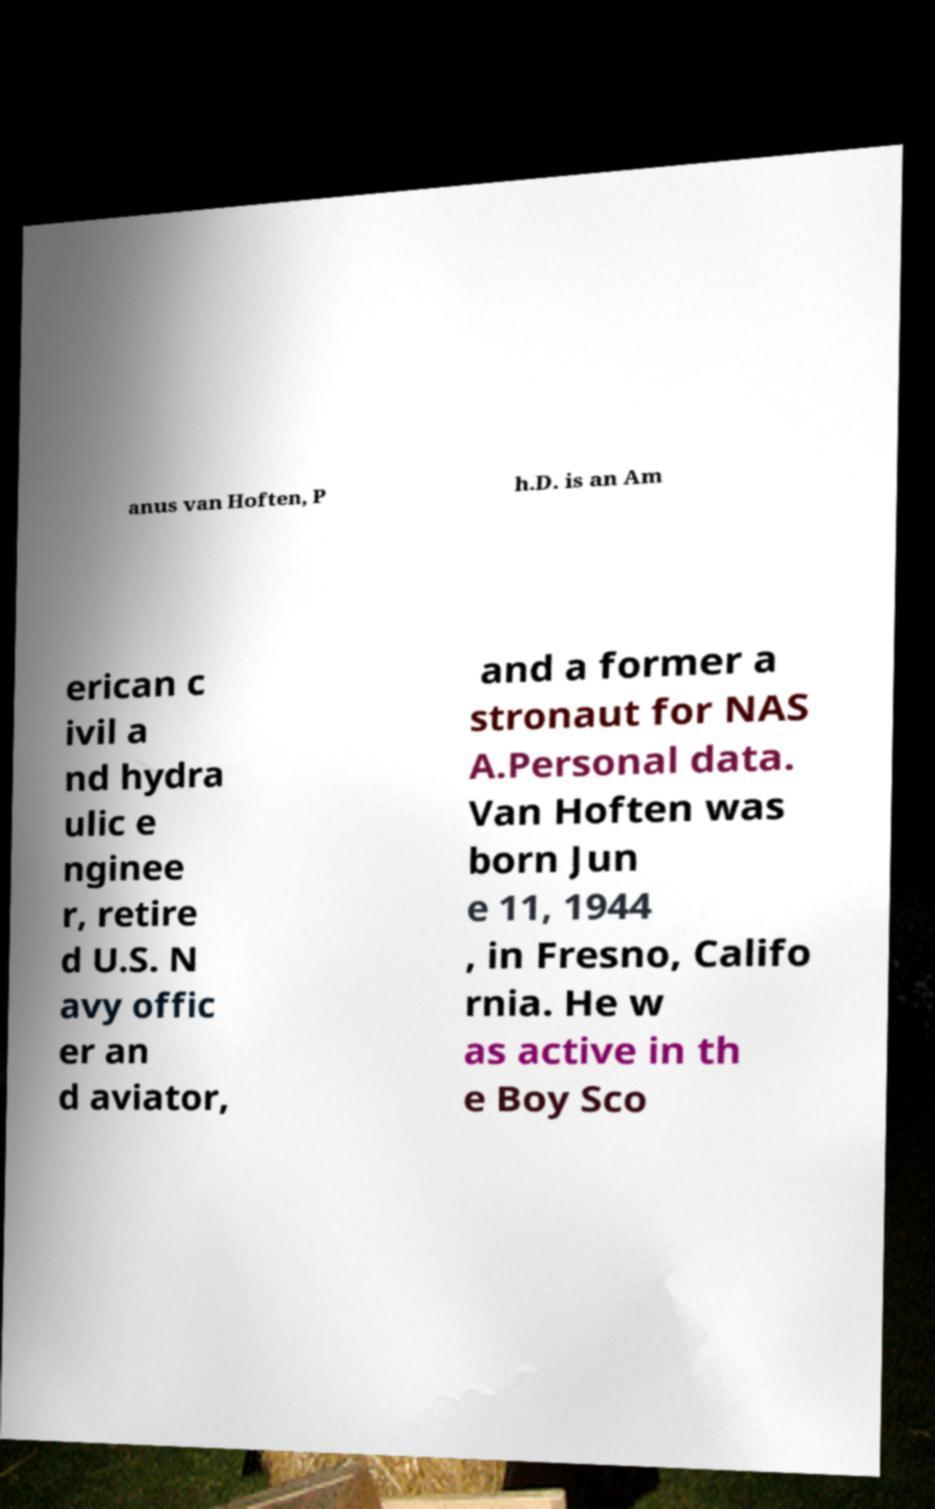Could you assist in decoding the text presented in this image and type it out clearly? anus van Hoften, P h.D. is an Am erican c ivil a nd hydra ulic e nginee r, retire d U.S. N avy offic er an d aviator, and a former a stronaut for NAS A.Personal data. Van Hoften was born Jun e 11, 1944 , in Fresno, Califo rnia. He w as active in th e Boy Sco 